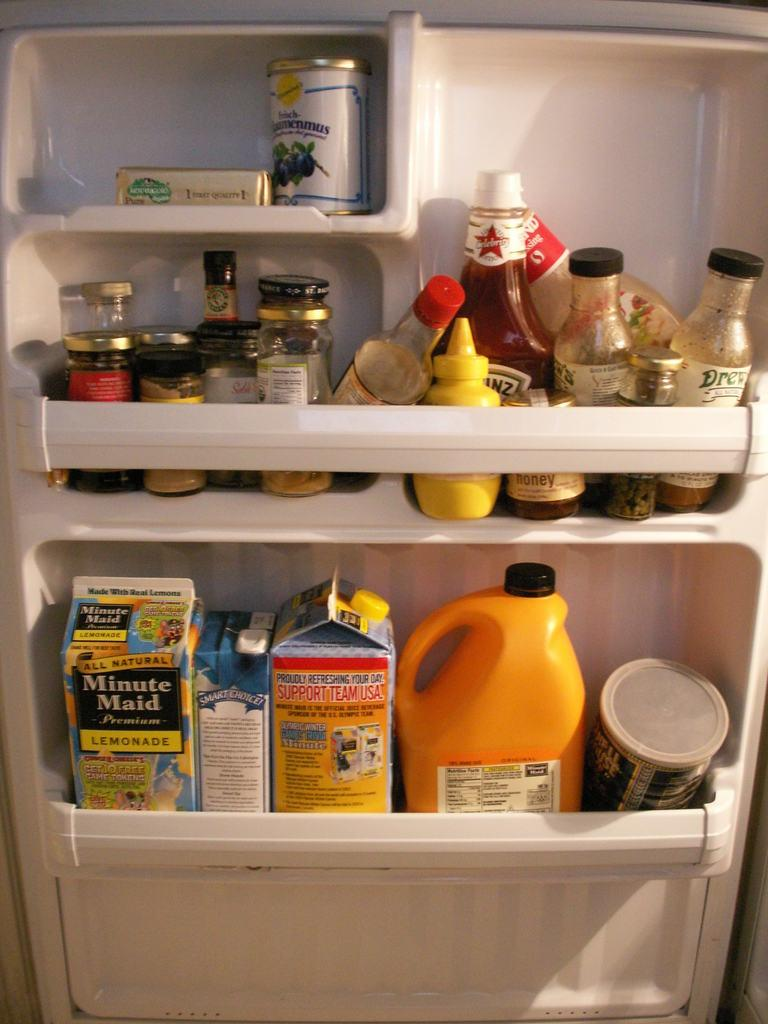<image>
Describe the image concisely. The refrigerator contains two cartons of Minute Maid lemonade. 